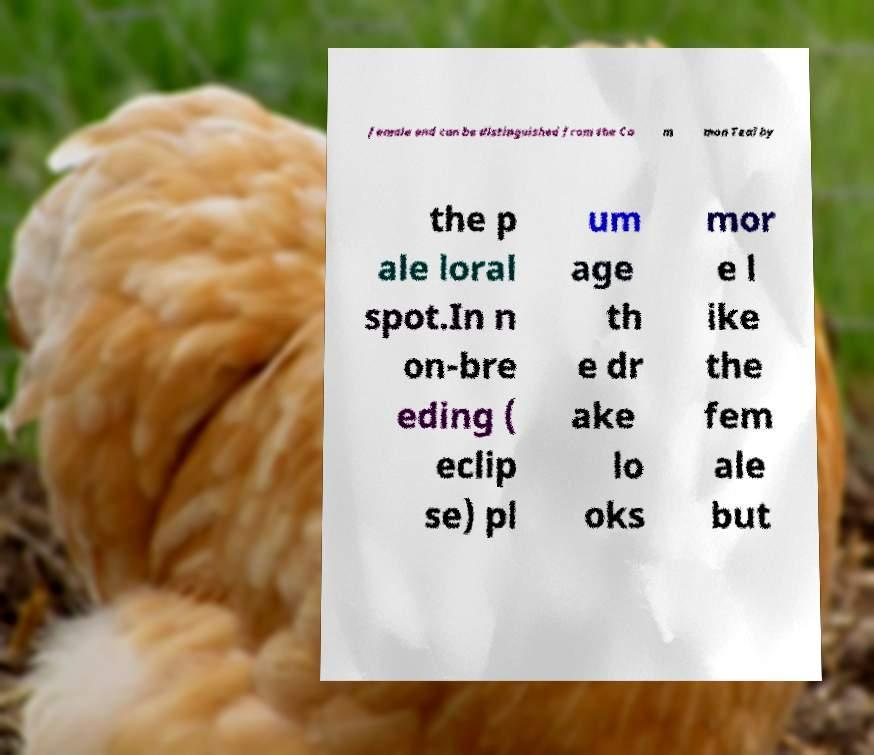I need the written content from this picture converted into text. Can you do that? female and can be distinguished from the Co m mon Teal by the p ale loral spot.In n on-bre eding ( eclip se) pl um age th e dr ake lo oks mor e l ike the fem ale but 